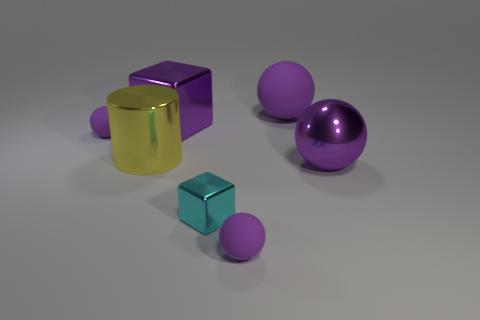How many purple spheres must be subtracted to get 1 purple spheres? 3 Subtract all large purple rubber balls. How many balls are left? 3 Add 2 tiny cyan things. How many objects exist? 9 Subtract all spheres. How many objects are left? 3 Subtract 0 red cylinders. How many objects are left? 7 Subtract all gray balls. Subtract all blue cylinders. How many balls are left? 4 Subtract all big blue matte objects. Subtract all cyan blocks. How many objects are left? 6 Add 7 big purple things. How many big purple things are left? 10 Add 3 blocks. How many blocks exist? 5 